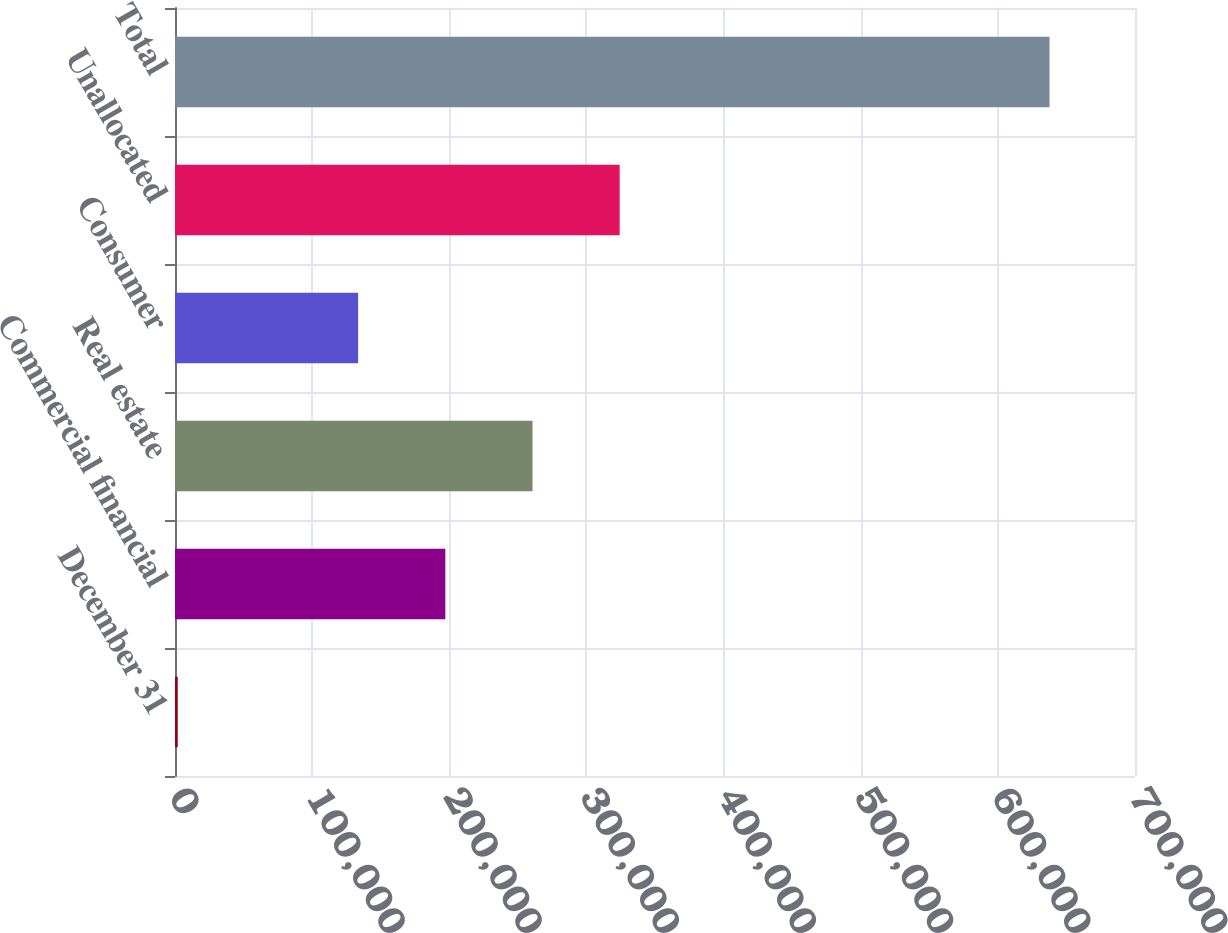Convert chart to OTSL. <chart><loc_0><loc_0><loc_500><loc_500><bar_chart><fcel>December 31<fcel>Commercial financial<fcel>Real estate<fcel>Consumer<fcel>Unallocated<fcel>Total<nl><fcel>2005<fcel>197107<fcel>260673<fcel>133541<fcel>324238<fcel>637663<nl></chart> 